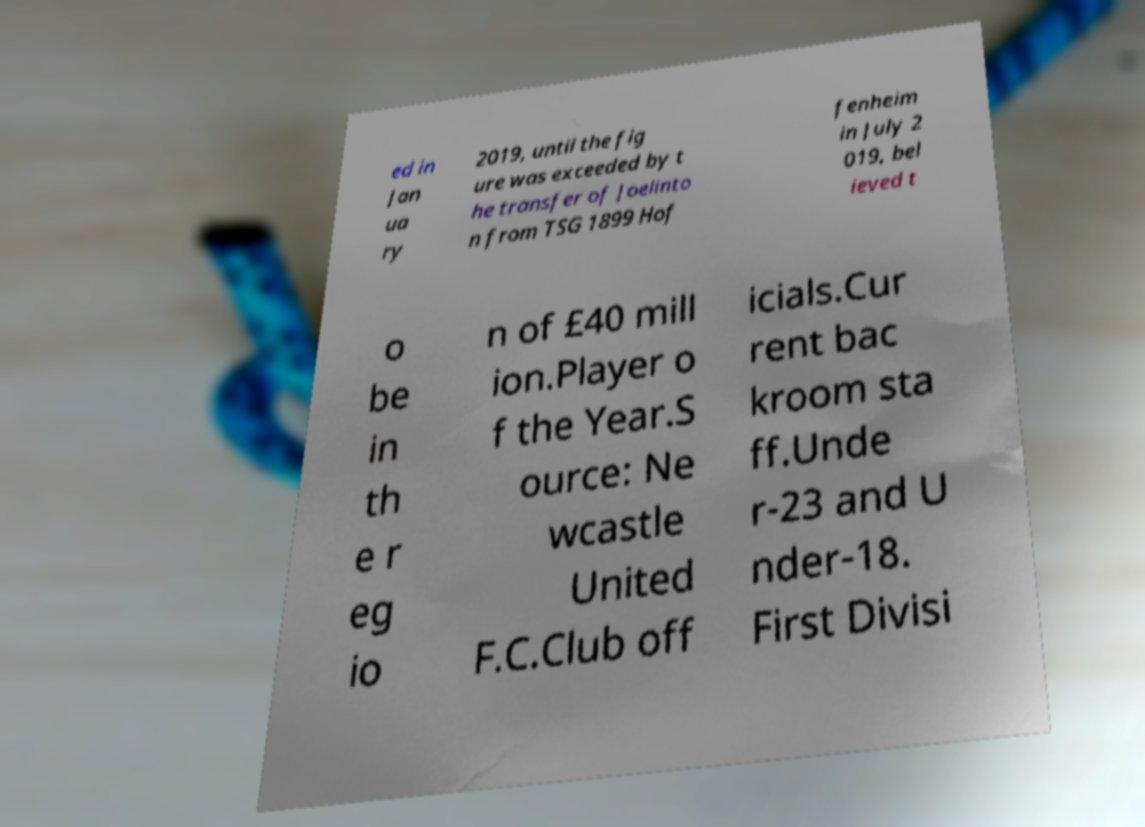Could you assist in decoding the text presented in this image and type it out clearly? ed in Jan ua ry 2019, until the fig ure was exceeded by t he transfer of Joelinto n from TSG 1899 Hof fenheim in July 2 019, bel ieved t o be in th e r eg io n of £40 mill ion.Player o f the Year.S ource: Ne wcastle United F.C.Club off icials.Cur rent bac kroom sta ff.Unde r-23 and U nder-18. First Divisi 